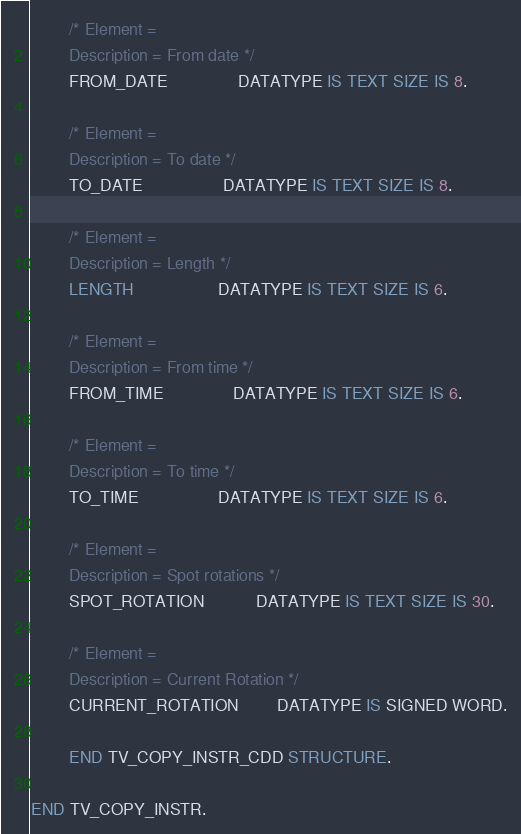<code> <loc_0><loc_0><loc_500><loc_500><_SQL_>
        /* Element =
        Description = From date */
        FROM_DATE               DATATYPE IS TEXT SIZE IS 8.

        /* Element =
        Description = To date */
        TO_DATE                 DATATYPE IS TEXT SIZE IS 8.

        /* Element =
        Description = Length */
        LENGTH                  DATATYPE IS TEXT SIZE IS 6.

        /* Element =
        Description = From time */
        FROM_TIME               DATATYPE IS TEXT SIZE IS 6.

        /* Element =
        Description = To time */
        TO_TIME                 DATATYPE IS TEXT SIZE IS 6.

        /* Element =
        Description = Spot rotations */
        SPOT_ROTATION           DATATYPE IS TEXT SIZE IS 30.

        /* Element =
        Description = Current Rotation */
        CURRENT_ROTATION        DATATYPE IS SIGNED WORD.

        END TV_COPY_INSTR_CDD STRUCTURE.

END TV_COPY_INSTR.
</code> 